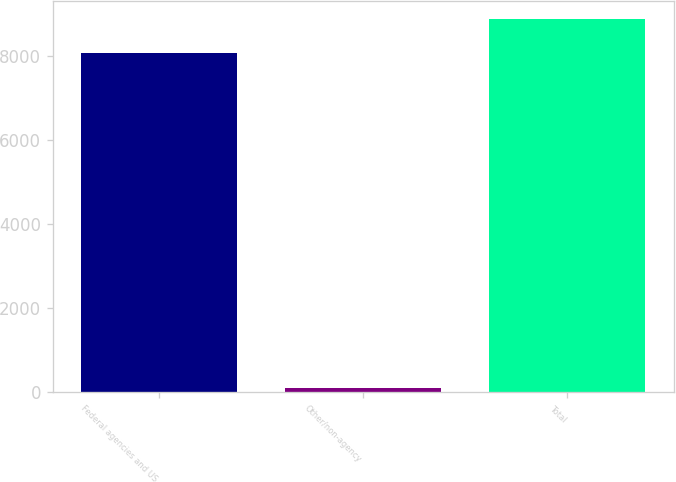Convert chart to OTSL. <chart><loc_0><loc_0><loc_500><loc_500><bar_chart><fcel>Federal agencies and US<fcel>Other/non-agency<fcel>Total<nl><fcel>8061<fcel>84<fcel>8867.1<nl></chart> 